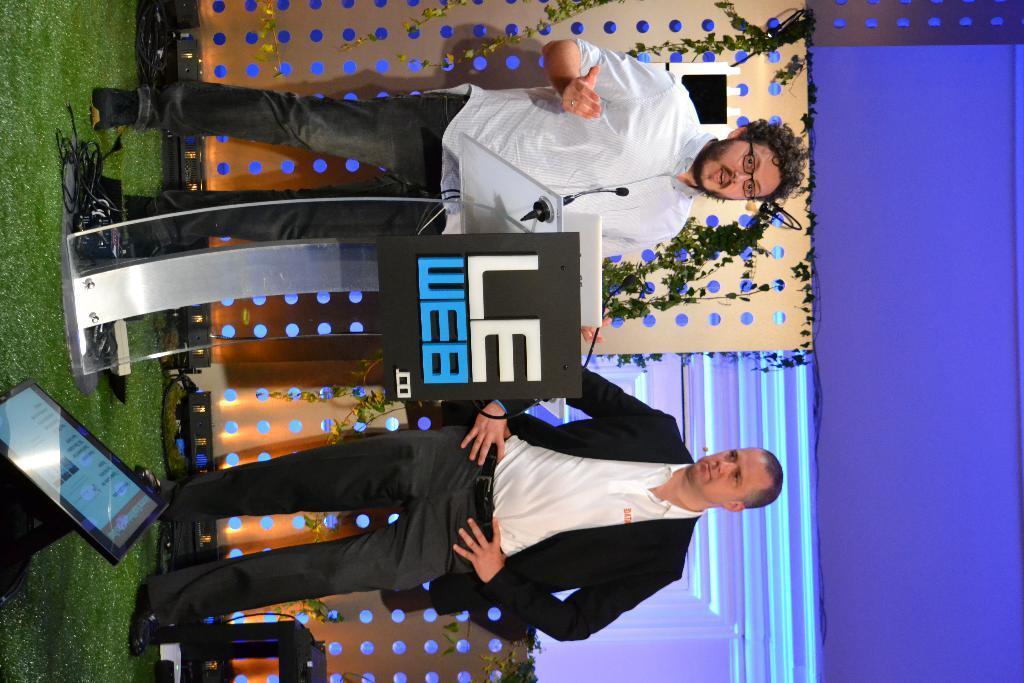Can you describe this image briefly? In this image I can see at the top a man is standing near the podium and speaking, at the bottom there is another man. On the left side there is an electronic display. 